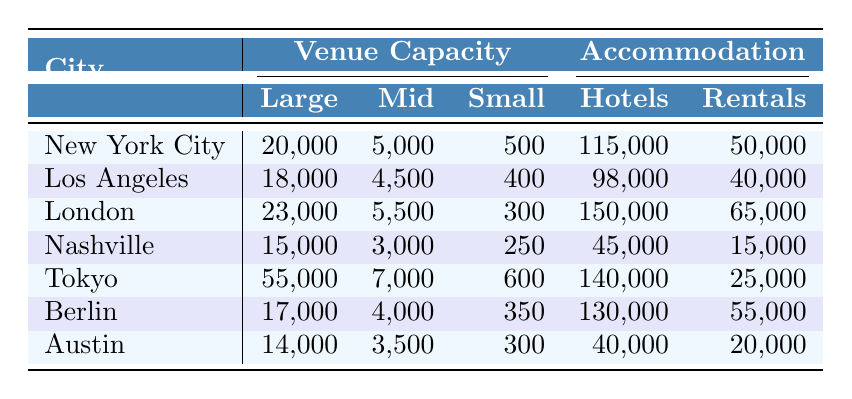What city has the highest large arena capacity? Looking at the "Large Arena Capacity" column, Tokyo has the highest value at 55,000.
Answer: Tokyo How many hotel rooms are available in London? The table shows that London has 150,000 hotel rooms available listed under the "Hotel Rooms Available" column.
Answer: 150,000 Which city has more short-term rentals: Los Angeles or Nashville? Los Angeles has 40,000 short-term rentals while Nashville has 15,000. A simple comparison shows that Los Angeles has more rentals.
Answer: Los Angeles What is the total capacity of small clubs in New York City and Berlin? Adding the capacities from New York City (500) and Berlin (350) gives 500 + 350 = 850.
Answer: 850 What is the average number of hotel rooms available across all listed cities? The total number of hotel rooms is (115,000 + 98,000 + 150,000 + 45,000 + 140,000 + 130,000 + 40,000) = 678,000. Dividing this by 7 gives an average of 678,000 / 7 ≈ 96,857.
Answer: 96,857 Is it true that Austin has more hotel rooms available than Nashville? Austin has 40,000 hotel rooms while Nashville has 45,000, therefore, it is false that Austin has more.
Answer: False What is the difference in the number of mid-size venue capacities between Tokyo and Austin? Tokyo has a mid-size capacity of 7,000, while Austin has 3,500. The difference is 7,000 - 3,500 = 3,500.
Answer: 3,500 Which city has the lowest total accommodation availability (sum of hotel rooms and short-term rentals)? Calculating total accommodation: Nashville has 45,000 + 15,000 = 60,000; Austin has 40,000 + 20,000 = 60,000. Both cities tie for the lowest total accommodations.
Answer: Nashville and Austin What percentage of the large arena capacity in London does the mid-size venue capacity represent? The mid-size capacity in London is 5,500 and the large arena capacity is 23,000. The percentage is (5,500 / 23,000) * 100 ≈ 23.91%.
Answer: 23.91% Which city has the greatest difference between their large arena capacity and mid-size venue capacity? The differences are calculated as follows: Tokyo (55,000 - 7,000 = 48,000), New York City (20,000 - 5,000 = 15,000). The greatest difference is with Tokyo at 48,000.
Answer: Tokyo 